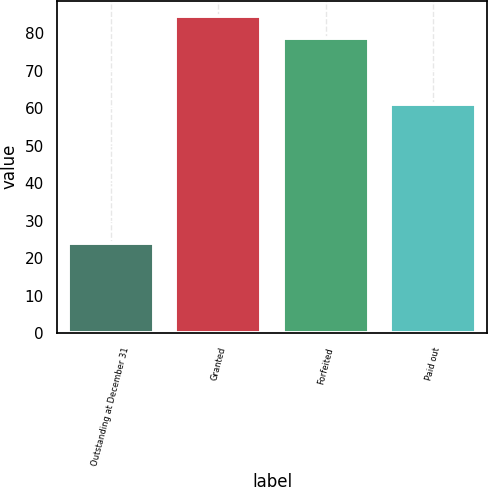<chart> <loc_0><loc_0><loc_500><loc_500><bar_chart><fcel>Outstanding at December 31<fcel>Granted<fcel>Forfeited<fcel>Paid out<nl><fcel>24.14<fcel>84.54<fcel>78.86<fcel>61.02<nl></chart> 